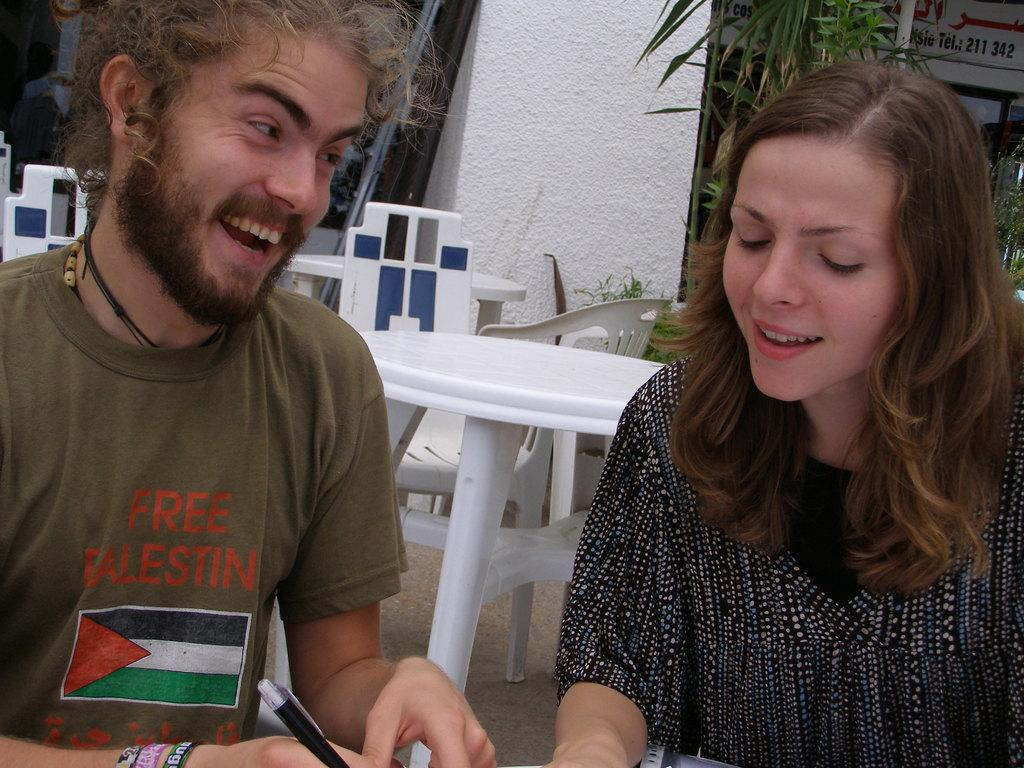How many people are present in the image? There is a man and a woman in the image. What objects are present in the image that people might sit on? There are tables and chairs in the image. What type of natural environment is visible in the image? There are trees in the image. What is the man holding in his hand? The man is holding a pen in his hand. What type of test is the man taking in the image? There is no test present in the image; the man is simply holding a pen in his hand. What hobbies does the woman have, as seen in the image? The image does not provide any information about the woman's hobbies. 